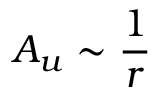<formula> <loc_0><loc_0><loc_500><loc_500>A _ { u } \sim \frac { 1 } { r }</formula> 